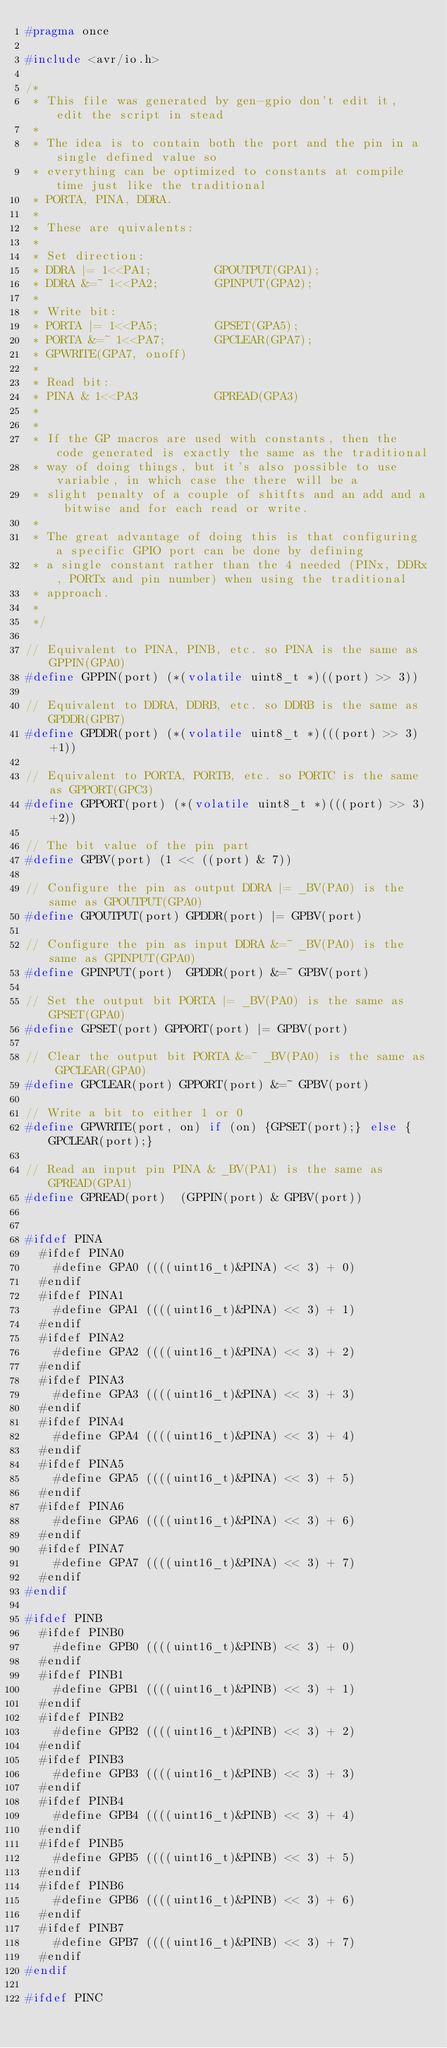Convert code to text. <code><loc_0><loc_0><loc_500><loc_500><_C_>#pragma once

#include <avr/io.h>

/*
 * This file was generated by gen-gpio don't edit it, edit the script in stead
 * 
 * The idea is to contain both the port and the pin in a single defined value so
 * everything can be optimized to constants at compile time just like the traditional
 * PORTA, PINA, DDRA.
 * 
 * These are quivalents:
 * 
 * Set direction:
 * DDRA |= 1<<PA1;         GPOUTPUT(GPA1);
 * DDRA &=~ 1<<PA2;        GPINPUT(GPA2);
 * 
 * Write bit:
 * PORTA |= 1<<PA5;        GPSET(GPA5);
 * PORTA &=~ 1<<PA7;       GPCLEAR(GPA7);
 * GPWRITE(GPA7, onoff)
 *
 * Read bit:
 * PINA & 1<<PA3           GPREAD(GPA3)
 * 
 * 
 * If the GP macros are used with constants, then the code generated is exactly the same as the traditional
 * way of doing things, but it's also possible to use variable, in which case the there will be a
 * slight penalty of a couple of shitfts and an add and a bitwise and for each read or write.
 * 
 * The great advantage of doing this is that configuring a specific GPIO port can be done by defining
 * a single constant rather than the 4 needed (PINx, DDRx, PORTx and pin number) when using the traditional
 * approach.
 * 
 */

// Equivalent to PINA, PINB, etc. so PINA is the same as GPPIN(GPA0)
#define GPPIN(port) (*(volatile uint8_t *)((port) >> 3))

// Equivalent to DDRA, DDRB, etc. so DDRB is the same as GPDDR(GPB7) 
#define GPDDR(port) (*(volatile uint8_t *)(((port) >> 3)+1))

// Equivalent to PORTA, PORTB, etc. so PORTC is the same as GPPORT(GPC3)
#define GPPORT(port) (*(volatile uint8_t *)(((port) >> 3)+2))

// The bit value of the pin part
#define GPBV(port) (1 << ((port) & 7))

// Configure the pin as output DDRA |= _BV(PA0) is the same as GPOUTPUT(GPA0)
#define GPOUTPUT(port) GPDDR(port) |= GPBV(port)

// Configure the pin as input DDRA &=~ _BV(PA0) is the same as GPINPUT(GPA0)
#define GPINPUT(port)  GPDDR(port) &=~ GPBV(port)

// Set the output bit PORTA |= _BV(PA0) is the same as GPSET(GPA0)
#define GPSET(port) GPPORT(port) |= GPBV(port)

// Clear the output bit PORTA &=~ _BV(PA0) is the same as GPCLEAR(GPA0)
#define GPCLEAR(port) GPPORT(port) &=~ GPBV(port)

// Write a bit to either 1 or 0
#define GPWRITE(port, on) if (on) {GPSET(port);} else {GPCLEAR(port);}

// Read an input pin PINA & _BV(PA1) is the same as GPREAD(GPA1)
#define GPREAD(port)  (GPPIN(port) & GPBV(port))


#ifdef PINA
  #ifdef PINA0
    #define GPA0 ((((uint16_t)&PINA) << 3) + 0)
  #endif
  #ifdef PINA1
    #define GPA1 ((((uint16_t)&PINA) << 3) + 1)
  #endif
  #ifdef PINA2
    #define GPA2 ((((uint16_t)&PINA) << 3) + 2)
  #endif
  #ifdef PINA3
    #define GPA3 ((((uint16_t)&PINA) << 3) + 3)
  #endif
  #ifdef PINA4
    #define GPA4 ((((uint16_t)&PINA) << 3) + 4)
  #endif
  #ifdef PINA5
    #define GPA5 ((((uint16_t)&PINA) << 3) + 5)
  #endif
  #ifdef PINA6
    #define GPA6 ((((uint16_t)&PINA) << 3) + 6)
  #endif
  #ifdef PINA7
    #define GPA7 ((((uint16_t)&PINA) << 3) + 7)
  #endif
#endif

#ifdef PINB
  #ifdef PINB0
    #define GPB0 ((((uint16_t)&PINB) << 3) + 0)
  #endif
  #ifdef PINB1
    #define GPB1 ((((uint16_t)&PINB) << 3) + 1)
  #endif
  #ifdef PINB2
    #define GPB2 ((((uint16_t)&PINB) << 3) + 2)
  #endif
  #ifdef PINB3
    #define GPB3 ((((uint16_t)&PINB) << 3) + 3)
  #endif
  #ifdef PINB4
    #define GPB4 ((((uint16_t)&PINB) << 3) + 4)
  #endif
  #ifdef PINB5
    #define GPB5 ((((uint16_t)&PINB) << 3) + 5)
  #endif
  #ifdef PINB6
    #define GPB6 ((((uint16_t)&PINB) << 3) + 6)
  #endif
  #ifdef PINB7
    #define GPB7 ((((uint16_t)&PINB) << 3) + 7)
  #endif
#endif

#ifdef PINC</code> 